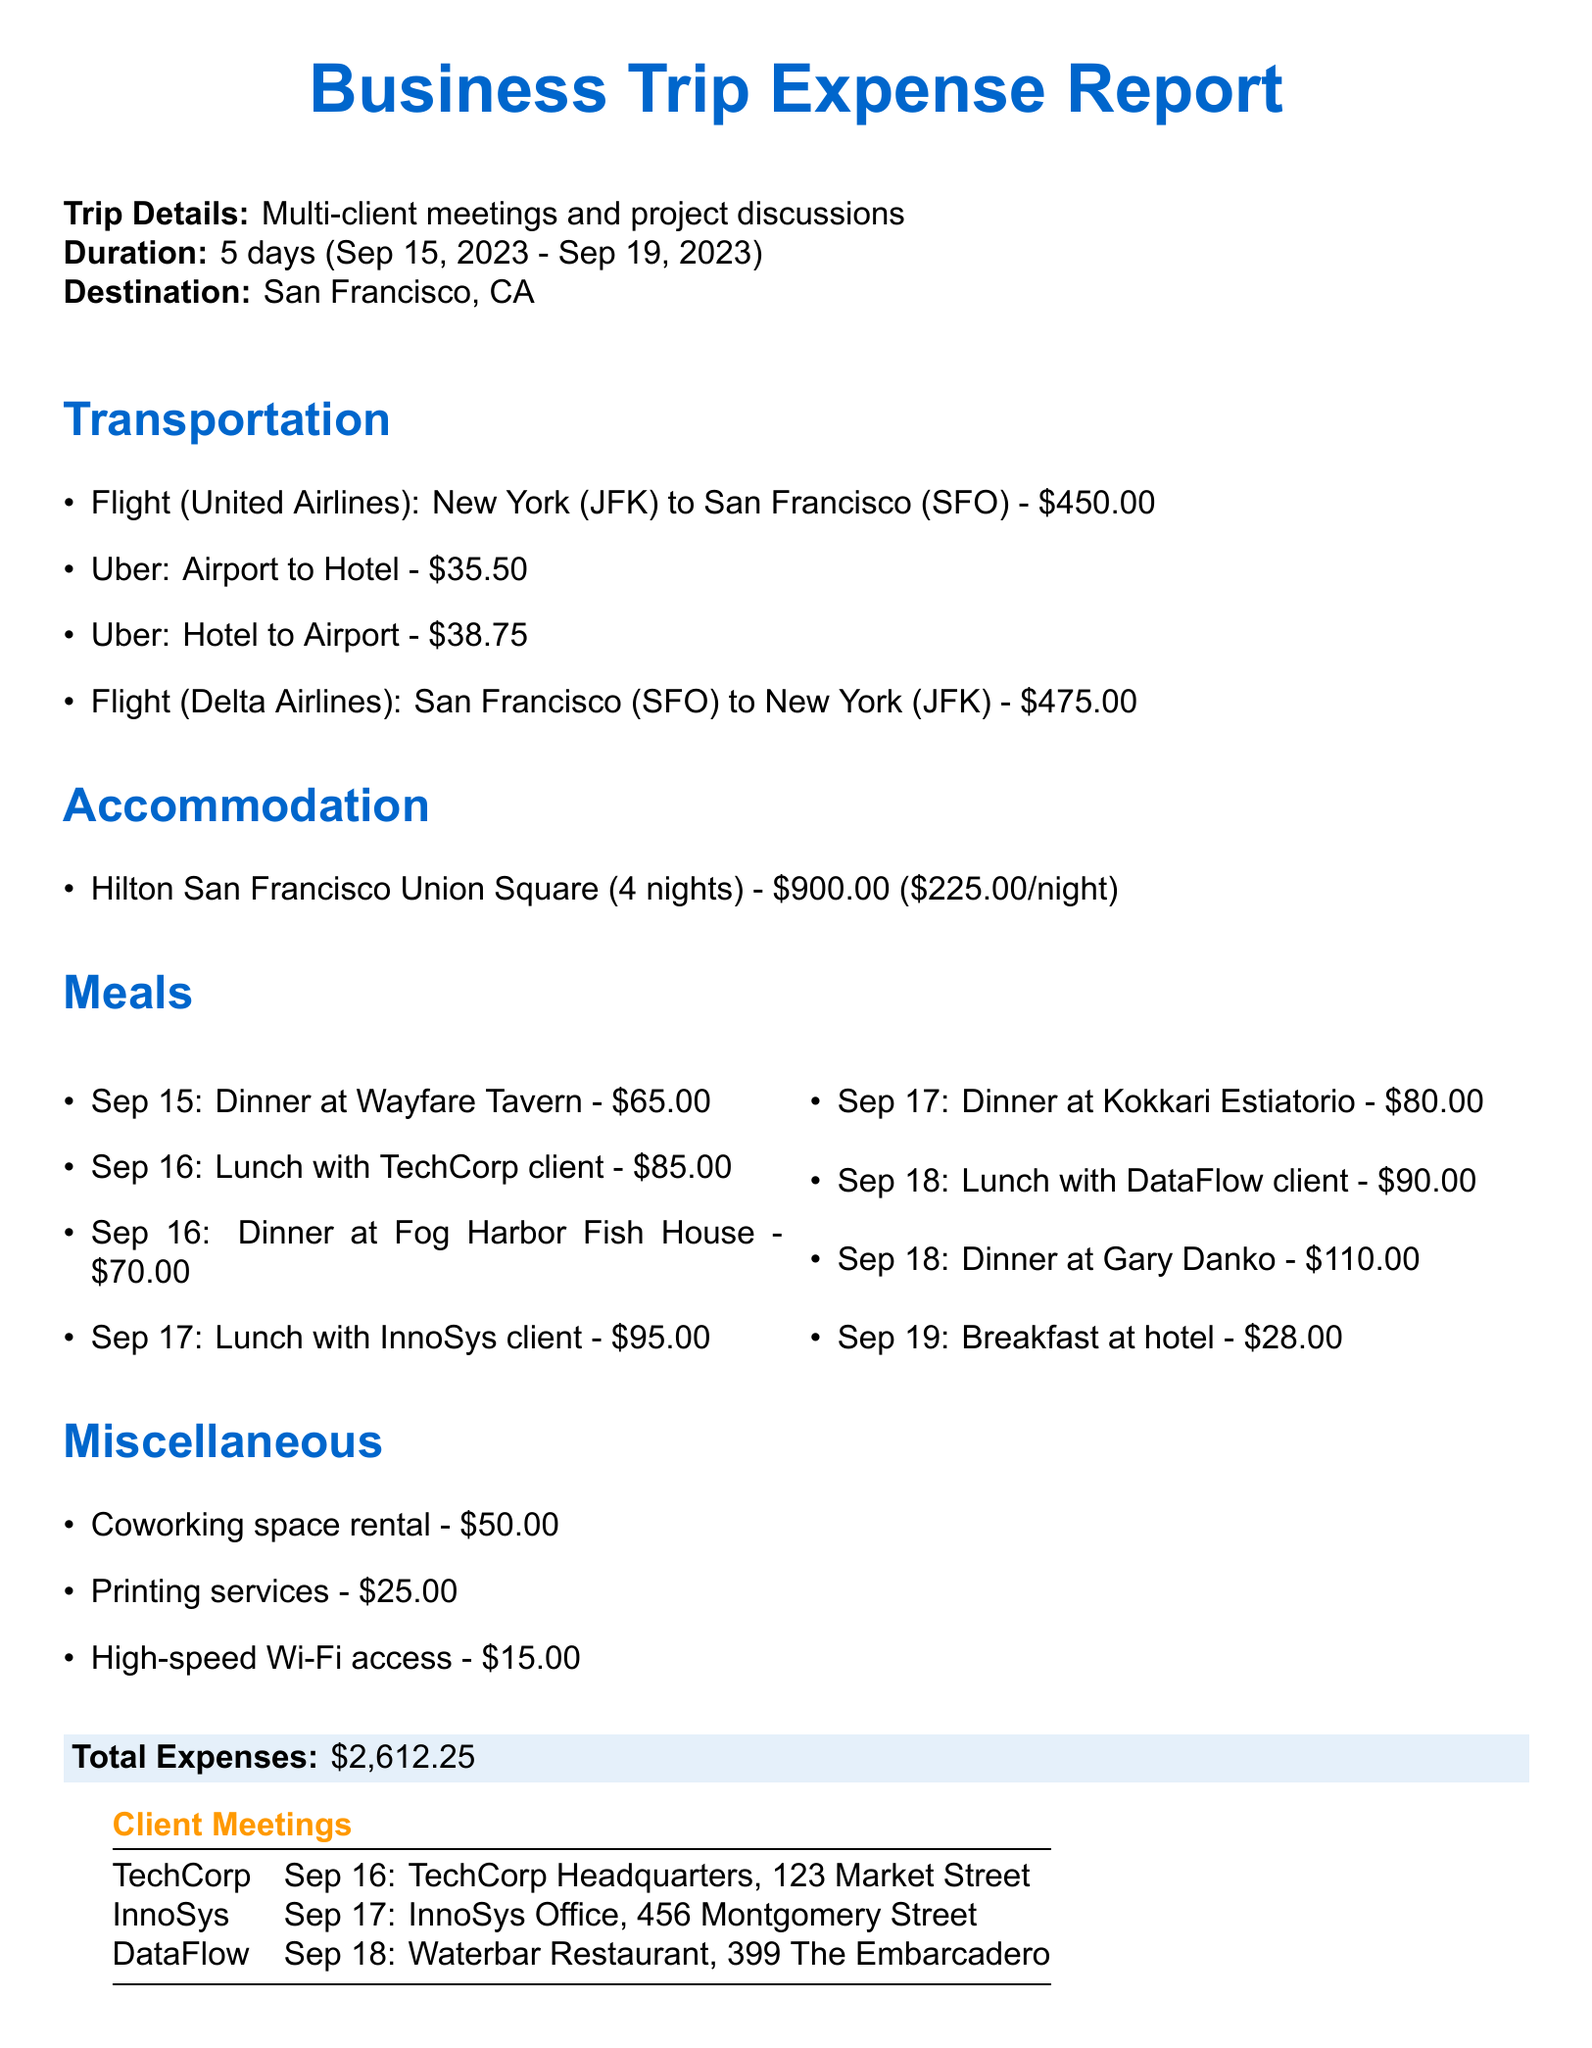what is the purpose of the trip? The purpose of the trip, as stated in the document, is "Multi-client meetings and project discussions."
Answer: Multi-client meetings and project discussions how long is the trip duration? The trip duration is defined as 5 days from departure to return.
Answer: 5 days what is the total cost of accommodation? The document specifies that the total cost for accommodation at Hilton San Francisco Union Square is $900.00.
Answer: $900.00 how much was spent on meals during the trip? The total meal costs are summed up from individual meal expenses, resulting in a total of $458.00.
Answer: $458.00 which hotel was used for accommodation? The document specifies the hotel name as "Hilton San Francisco Union Square".
Answer: Hilton San Francisco Union Square what was the cost of the flight from New York to San Francisco? The document states that the cost of the flight with United Airlines is $450.00.
Answer: $450.00 when was the meeting with TechCorp? According to the document, the meeting with TechCorp took place on September 16, 2023.
Answer: September 16, 2023 how many nights was the accommodation booked for? The document states that the accommodation was booked for 4 nights.
Answer: 4 nights what type of transportation was used from Airport to Hotel? The document indicates that an "Uber" was used for transportation from Airport to Hotel.
Answer: Uber 